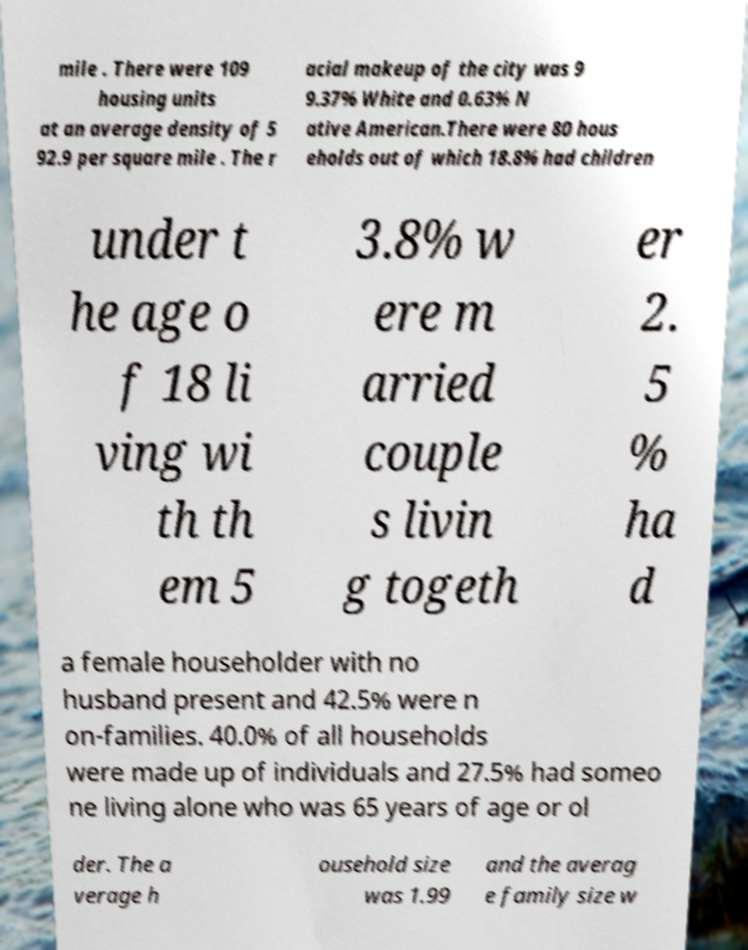What messages or text are displayed in this image? I need them in a readable, typed format. mile . There were 109 housing units at an average density of 5 92.9 per square mile . The r acial makeup of the city was 9 9.37% White and 0.63% N ative American.There were 80 hous eholds out of which 18.8% had children under t he age o f 18 li ving wi th th em 5 3.8% w ere m arried couple s livin g togeth er 2. 5 % ha d a female householder with no husband present and 42.5% were n on-families. 40.0% of all households were made up of individuals and 27.5% had someo ne living alone who was 65 years of age or ol der. The a verage h ousehold size was 1.99 and the averag e family size w 